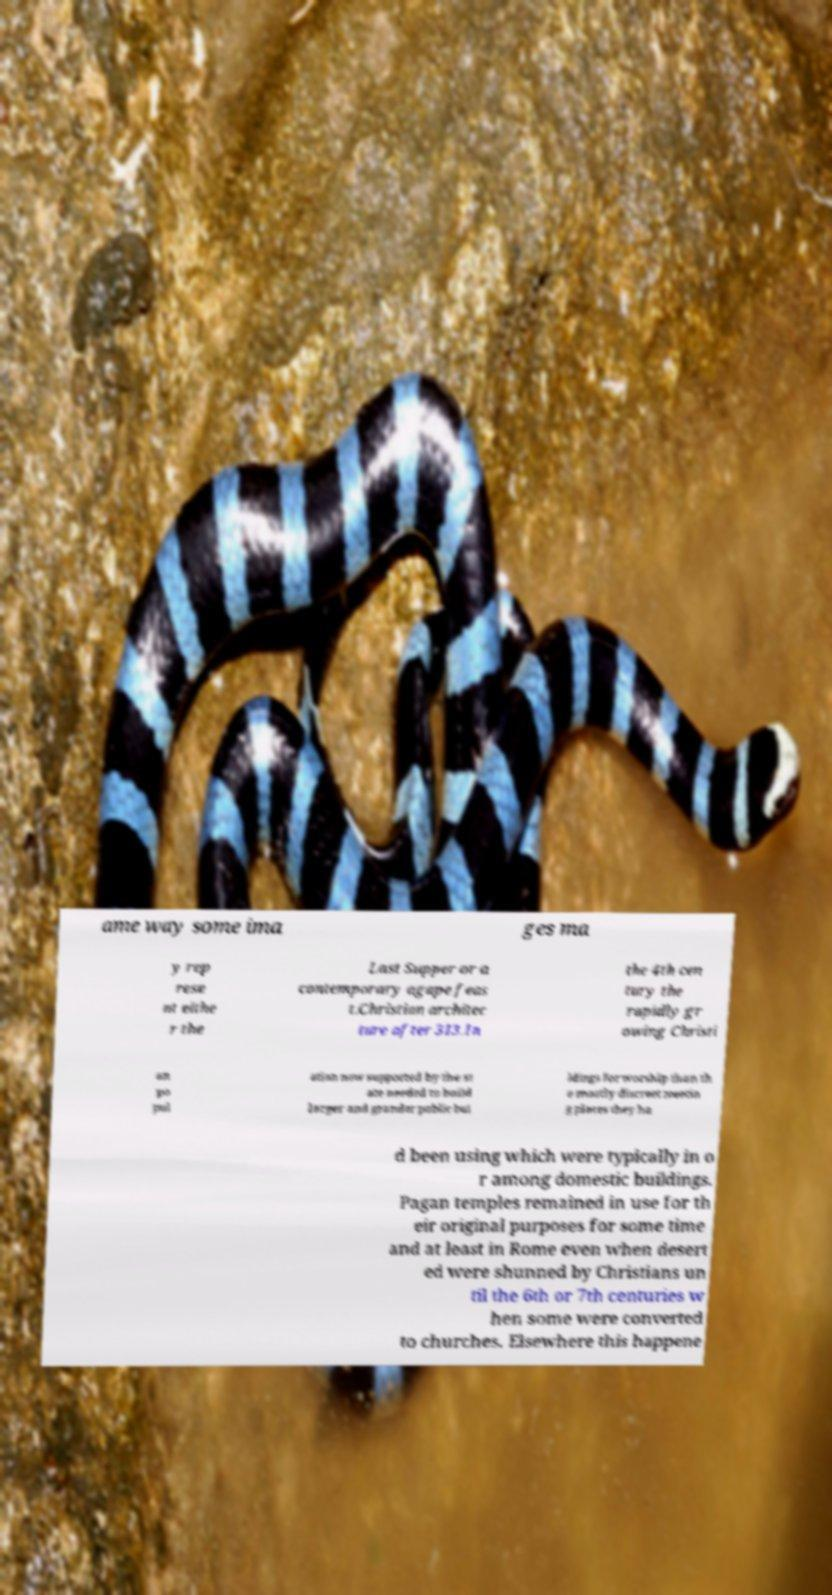Can you accurately transcribe the text from the provided image for me? ame way some ima ges ma y rep rese nt eithe r the Last Supper or a contemporary agape feas t.Christian architec ture after 313.In the 4th cen tury the rapidly gr owing Christi an po pul ation now supported by the st ate needed to build larger and grander public bui ldings for worship than th e mostly discreet meetin g places they ha d been using which were typically in o r among domestic buildings. Pagan temples remained in use for th eir original purposes for some time and at least in Rome even when desert ed were shunned by Christians un til the 6th or 7th centuries w hen some were converted to churches. Elsewhere this happene 